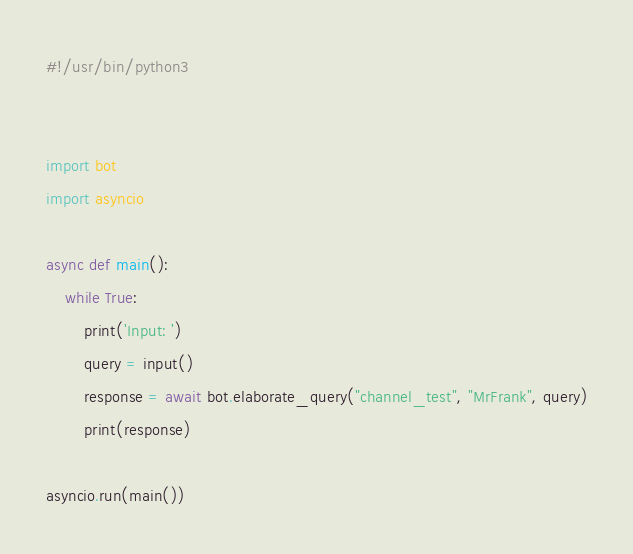<code> <loc_0><loc_0><loc_500><loc_500><_Python_>#!/usr/bin/python3


import bot
import asyncio

async def main():
    while True:
        print('Input: ')
        query = input()
        response = await bot.elaborate_query("channel_test", "MrFrank", query)
        print(response)

asyncio.run(main())</code> 